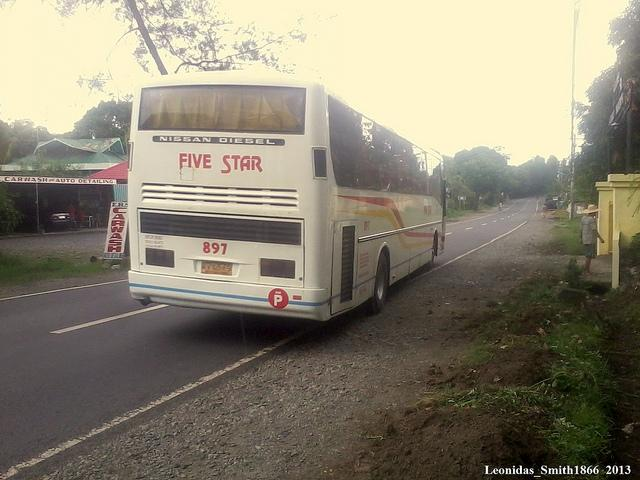The D word here refers to what? diesel 